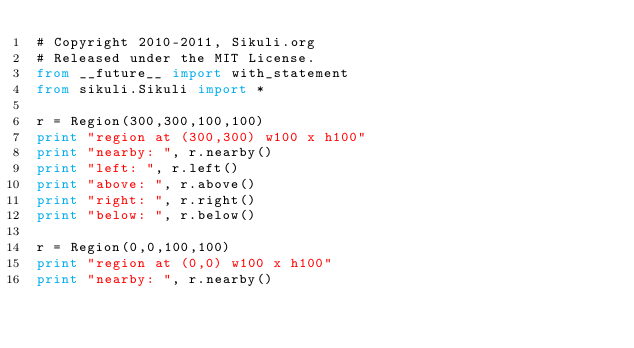Convert code to text. <code><loc_0><loc_0><loc_500><loc_500><_Python_># Copyright 2010-2011, Sikuli.org
# Released under the MIT License.
from __future__ import with_statement
from sikuli.Sikuli import *

r = Region(300,300,100,100)
print "region at (300,300) w100 x h100"
print "nearby: ", r.nearby()
print "left: ", r.left()
print "above: ", r.above()
print "right: ", r.right()
print "below: ", r.below()

r = Region(0,0,100,100)
print "region at (0,0) w100 x h100"
print "nearby: ", r.nearby()
</code> 